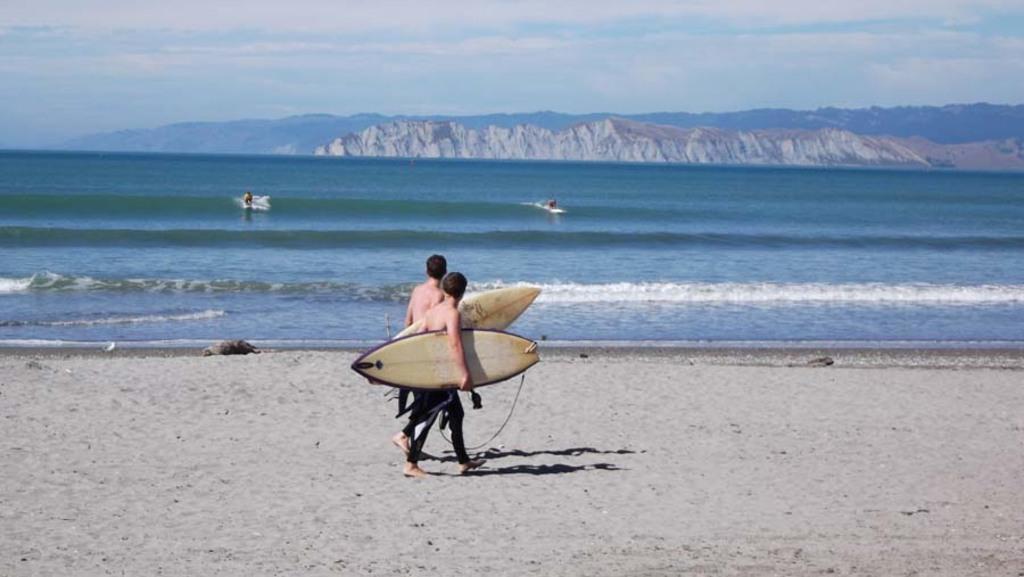How would you summarize this image in a sentence or two? In this picture we can see two men walking holding their surfboards in their hands on sand and in background we can see water, mountains, sky with clouds. 